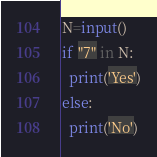<code> <loc_0><loc_0><loc_500><loc_500><_Python_>N=input()
if "7" in N:
  print('Yes')
else:
  print('No')</code> 